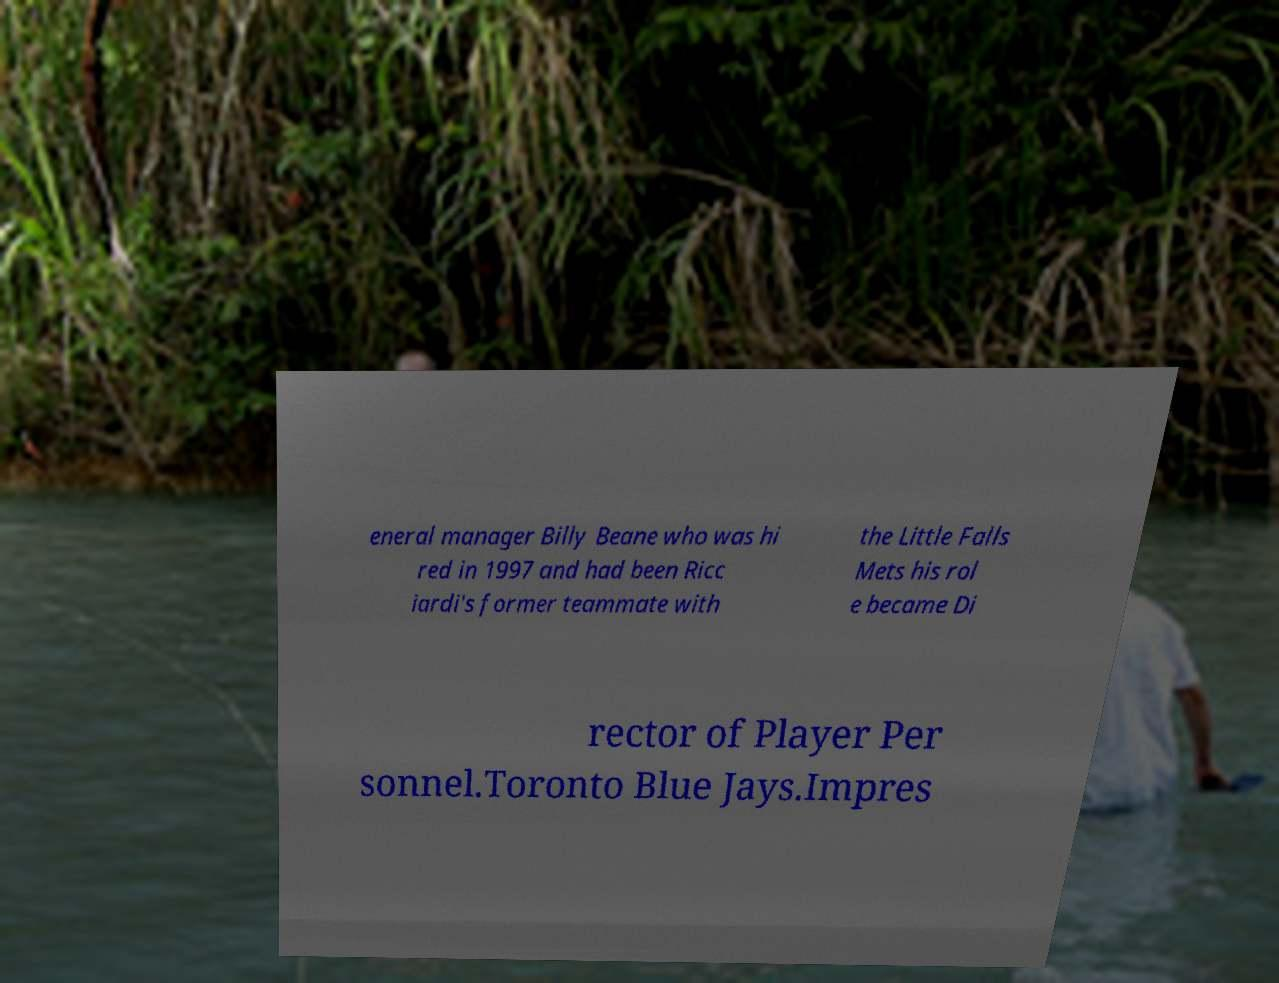What messages or text are displayed in this image? I need them in a readable, typed format. eneral manager Billy Beane who was hi red in 1997 and had been Ricc iardi's former teammate with the Little Falls Mets his rol e became Di rector of Player Per sonnel.Toronto Blue Jays.Impres 